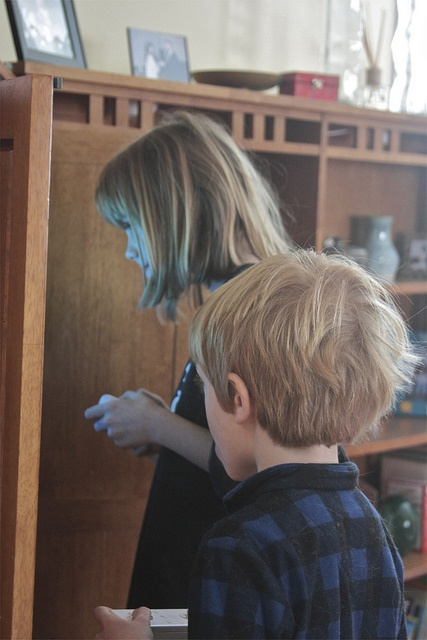Describe the objects in this image and their specific colors. I can see people in lightgray, black, gray, and darkgray tones, people in lightgray, gray, black, and darkgray tones, vase in lightgray, darkgray, and gray tones, vase in lightgray, gray, and black tones, and vase in lightgray and darkgray tones in this image. 